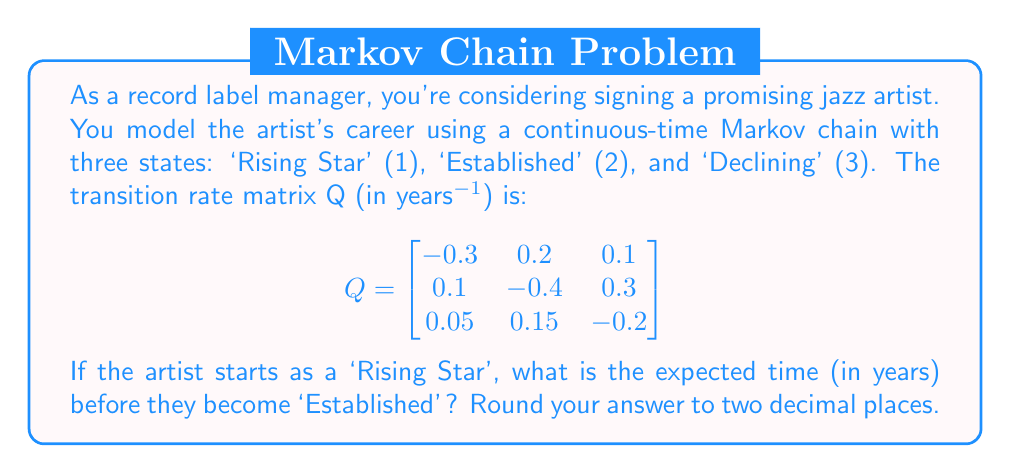Teach me how to tackle this problem. To solve this problem, we need to use the concept of mean first passage times in continuous-time Markov chains. We're interested in the expected time to go from state 1 (Rising Star) to state 2 (Established).

Step 1: Define the mean first passage time.
Let $m_{ij}$ be the expected time to reach state j starting from state i. We want to find $m_{12}$.

Step 2: Set up the system of equations.
For a continuous-time Markov chain, the mean first passage times satisfy:

$$ \sum_{k \neq j} q_{ik} m_{kj} - q_{ii} m_{ij} = -1 $$

For our problem, we need to solve:

$$ q_{13} m_{32} - q_{11} m_{12} = -1 $$
$$ q_{31} m_{12} + q_{32} m_{22} - q_{33} m_{32} = -1 $$

Step 3: Substitute the values from the Q matrix.
$$ 0.1 m_{32} - (-0.3) m_{12} = -1 $$
$$ 0.05 m_{12} + 0.15 m_{22} - (-0.2) m_{32} = -1 $$

Step 4: Simplify and solve the system of equations.
$$ 0.1 m_{32} + 0.3 m_{12} = 1 $$
$$ 0.05 m_{12} + 0.15 m_{22} + 0.2 m_{32} = 1 $$

We also know that $m_{22} = 0$ (as the expected time to reach state 2 from state 2 is 0).

Substituting this into the second equation:
$$ 0.05 m_{12} + 0.2 m_{32} = 1 $$

Now we have two equations with two unknowns:
$$ 0.1 m_{32} + 0.3 m_{12} = 1 $$
$$ 0.05 m_{12} + 0.2 m_{32} = 1 $$

Solving this system:
$$ m_{12} = 3.33 $$
$$ m_{32} = 4.44 $$

Step 5: Round the result to two decimal places.
The expected time to go from 'Rising Star' to 'Established' is 3.33 years.
Answer: 3.33 years 